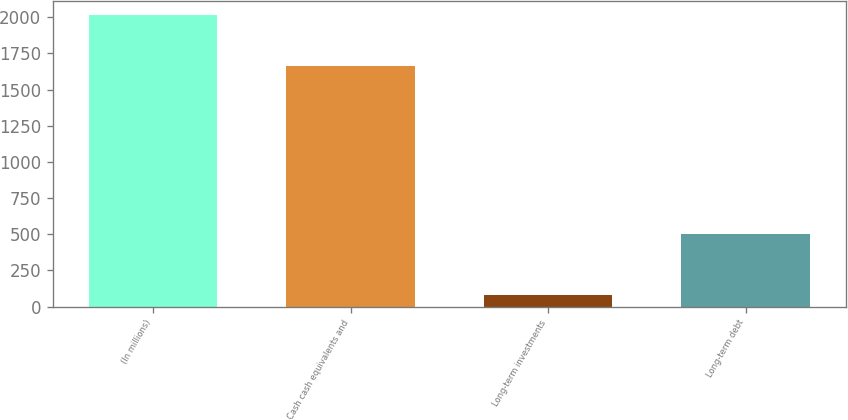Convert chart. <chart><loc_0><loc_0><loc_500><loc_500><bar_chart><fcel>(In millions)<fcel>Cash cash equivalents and<fcel>Long-term investments<fcel>Long-term debt<nl><fcel>2013<fcel>1661<fcel>83<fcel>499<nl></chart> 